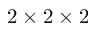<formula> <loc_0><loc_0><loc_500><loc_500>2 \times 2 \times 2</formula> 